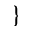<formula> <loc_0><loc_0><loc_500><loc_500>\}</formula> 